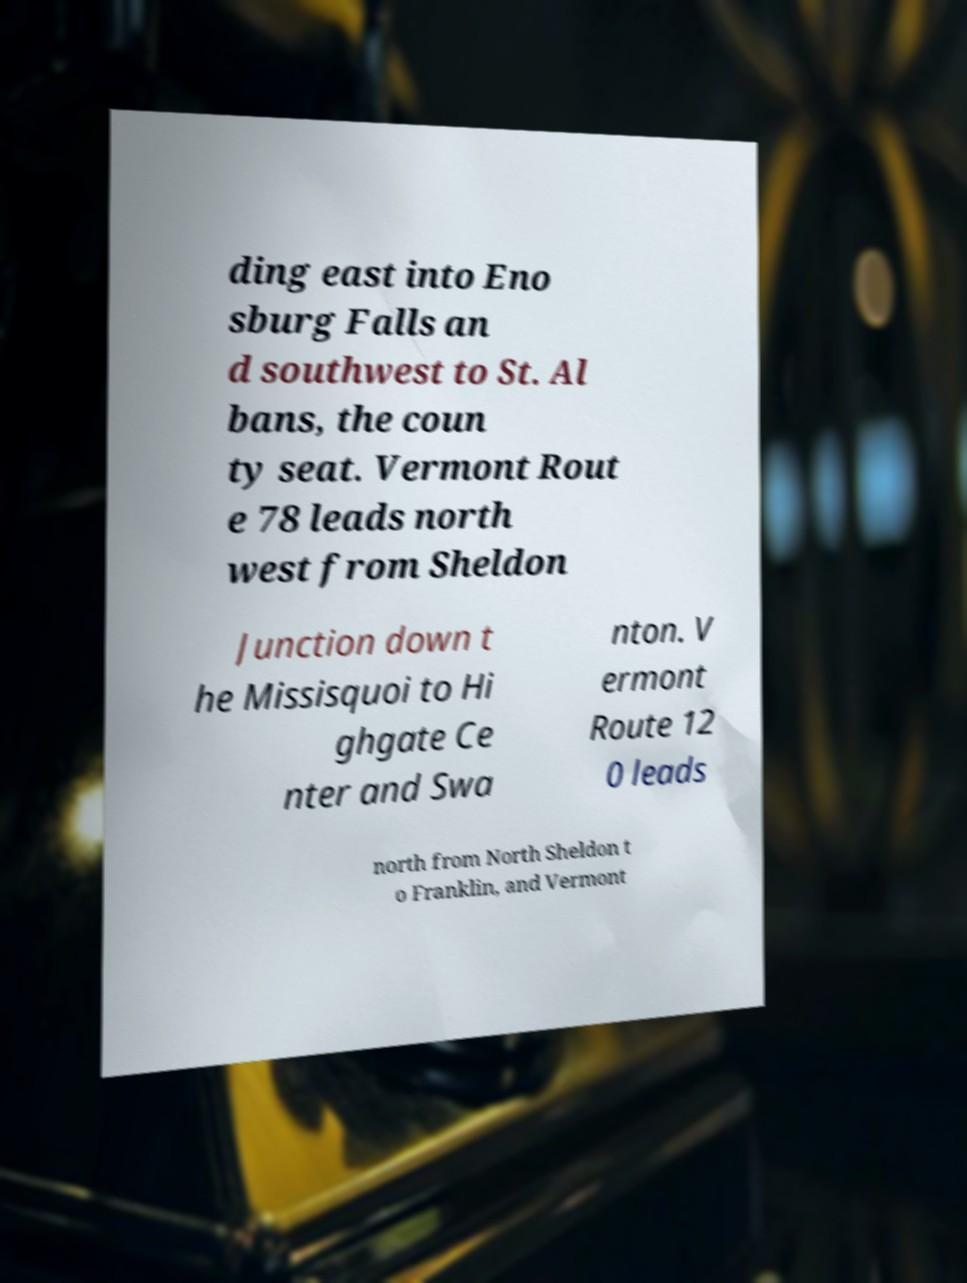What messages or text are displayed in this image? I need them in a readable, typed format. ding east into Eno sburg Falls an d southwest to St. Al bans, the coun ty seat. Vermont Rout e 78 leads north west from Sheldon Junction down t he Missisquoi to Hi ghgate Ce nter and Swa nton. V ermont Route 12 0 leads north from North Sheldon t o Franklin, and Vermont 